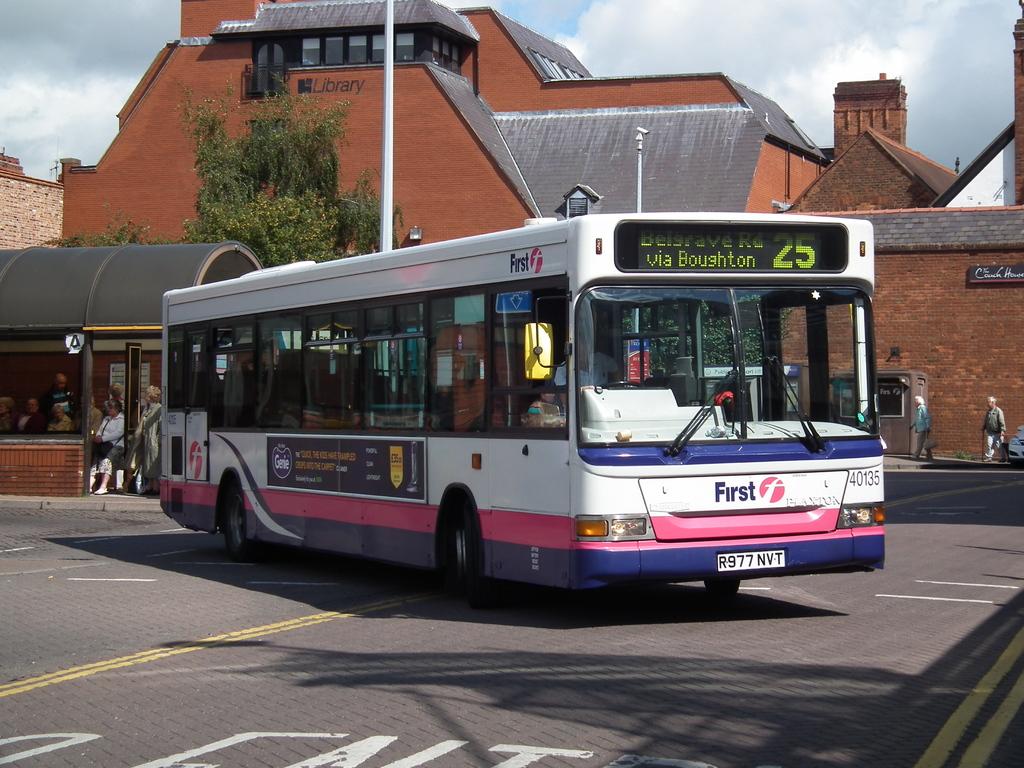What is the bus number?
Make the answer very short. 25. What type of public facility is this bus driving away from?
Give a very brief answer. Library. 